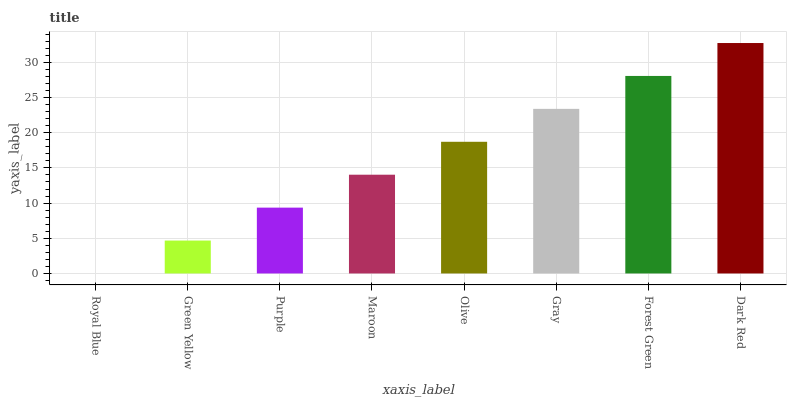Is Green Yellow the minimum?
Answer yes or no. No. Is Green Yellow the maximum?
Answer yes or no. No. Is Green Yellow greater than Royal Blue?
Answer yes or no. Yes. Is Royal Blue less than Green Yellow?
Answer yes or no. Yes. Is Royal Blue greater than Green Yellow?
Answer yes or no. No. Is Green Yellow less than Royal Blue?
Answer yes or no. No. Is Olive the high median?
Answer yes or no. Yes. Is Maroon the low median?
Answer yes or no. Yes. Is Purple the high median?
Answer yes or no. No. Is Green Yellow the low median?
Answer yes or no. No. 